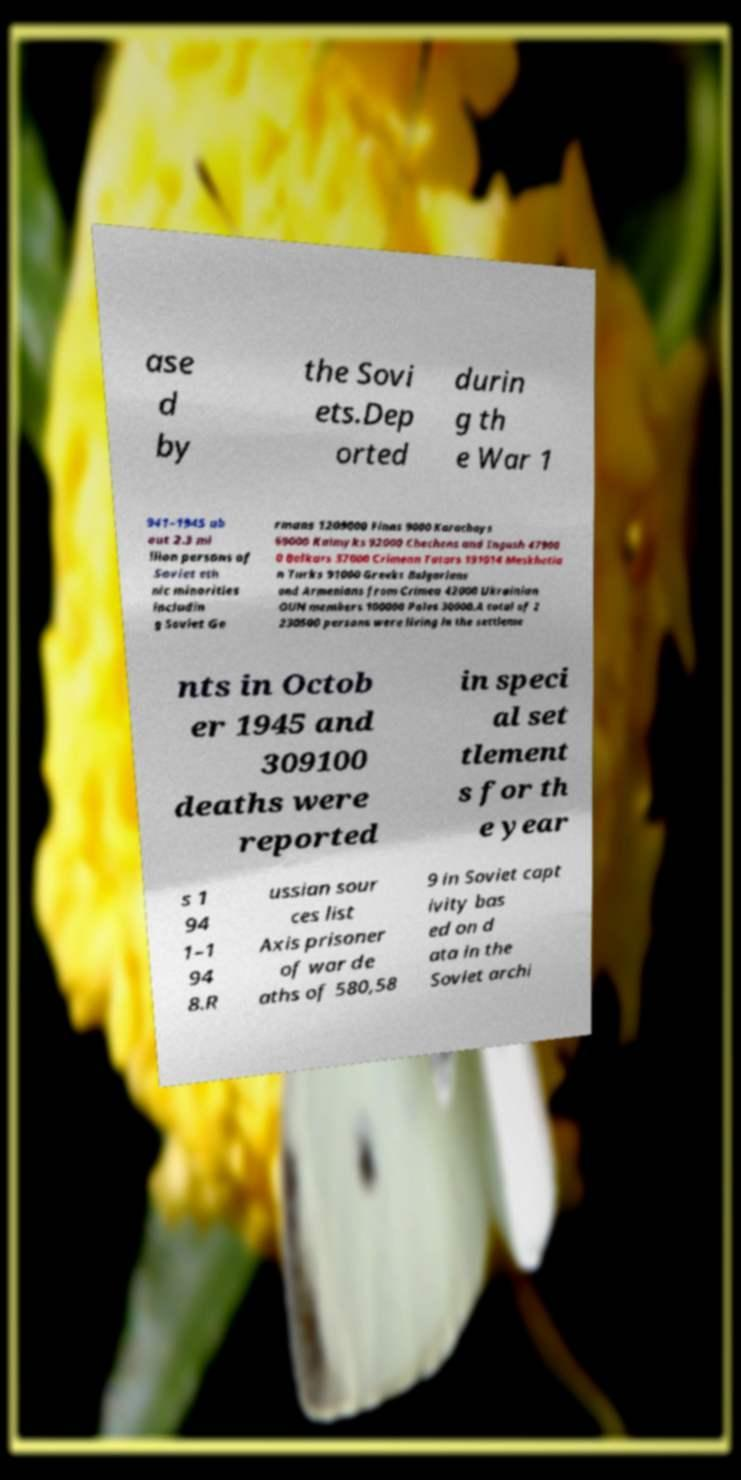What messages or text are displayed in this image? I need them in a readable, typed format. ase d by the Sovi ets.Dep orted durin g th e War 1 941–1945 ab out 2.3 mi llion persons of Soviet eth nic minorities includin g Soviet Ge rmans 1209000 Finns 9000 Karachays 69000 Kalmyks 92000 Chechens and Ingush 47900 0 Balkars 37000 Crimean Tatars 191014 Meskhetia n Turks 91000 Greeks Bulgarians and Armenians from Crimea 42000 Ukrainian OUN members 100000 Poles 30000.A total of 2 230500 persons were living in the settleme nts in Octob er 1945 and 309100 deaths were reported in speci al set tlement s for th e year s 1 94 1–1 94 8.R ussian sour ces list Axis prisoner of war de aths of 580,58 9 in Soviet capt ivity bas ed on d ata in the Soviet archi 